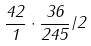Convert formula to latex. <formula><loc_0><loc_0><loc_500><loc_500>\frac { 4 2 } { 1 } \cdot \frac { 3 6 } { 2 4 5 } / 2</formula> 